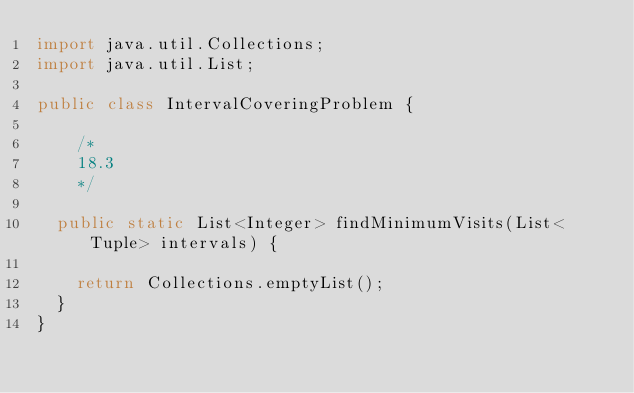<code> <loc_0><loc_0><loc_500><loc_500><_Java_>import java.util.Collections;
import java.util.List;

public class IntervalCoveringProblem {

    /*
    18.3
    */

  public static List<Integer> findMinimumVisits(List<Tuple> intervals) {

    return Collections.emptyList();
  }
}
</code> 